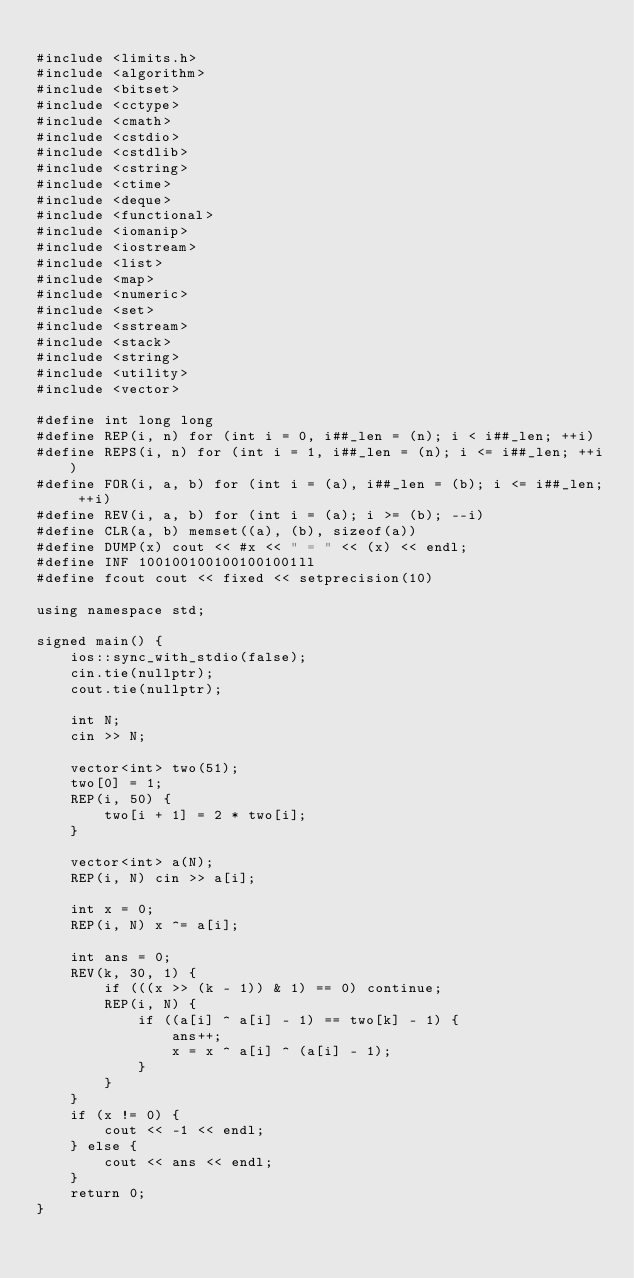Convert code to text. <code><loc_0><loc_0><loc_500><loc_500><_C++_>
#include <limits.h>
#include <algorithm>
#include <bitset>
#include <cctype>
#include <cmath>
#include <cstdio>
#include <cstdlib>
#include <cstring>
#include <ctime>
#include <deque>
#include <functional>
#include <iomanip>
#include <iostream>
#include <list>
#include <map>
#include <numeric>
#include <set>
#include <sstream>
#include <stack>
#include <string>
#include <utility>
#include <vector>

#define int long long
#define REP(i, n) for (int i = 0, i##_len = (n); i < i##_len; ++i)
#define REPS(i, n) for (int i = 1, i##_len = (n); i <= i##_len; ++i)
#define FOR(i, a, b) for (int i = (a), i##_len = (b); i <= i##_len; ++i)
#define REV(i, a, b) for (int i = (a); i >= (b); --i)
#define CLR(a, b) memset((a), (b), sizeof(a))
#define DUMP(x) cout << #x << " = " << (x) << endl;
#define INF 1001001001001001001ll
#define fcout cout << fixed << setprecision(10)

using namespace std;

signed main() {
    ios::sync_with_stdio(false);
    cin.tie(nullptr);
    cout.tie(nullptr);

    int N;
    cin >> N;

    vector<int> two(51);
    two[0] = 1;
    REP(i, 50) {
        two[i + 1] = 2 * two[i];
    }

    vector<int> a(N);
    REP(i, N) cin >> a[i];

    int x = 0;
    REP(i, N) x ^= a[i];

    int ans = 0;
    REV(k, 30, 1) {
        if (((x >> (k - 1)) & 1) == 0) continue;
        REP(i, N) {
            if ((a[i] ^ a[i] - 1) == two[k] - 1) {
                ans++;
                x = x ^ a[i] ^ (a[i] - 1);
            }
        }
    }
    if (x != 0) {
        cout << -1 << endl;
    } else {
        cout << ans << endl;
    }
    return 0;
}
</code> 